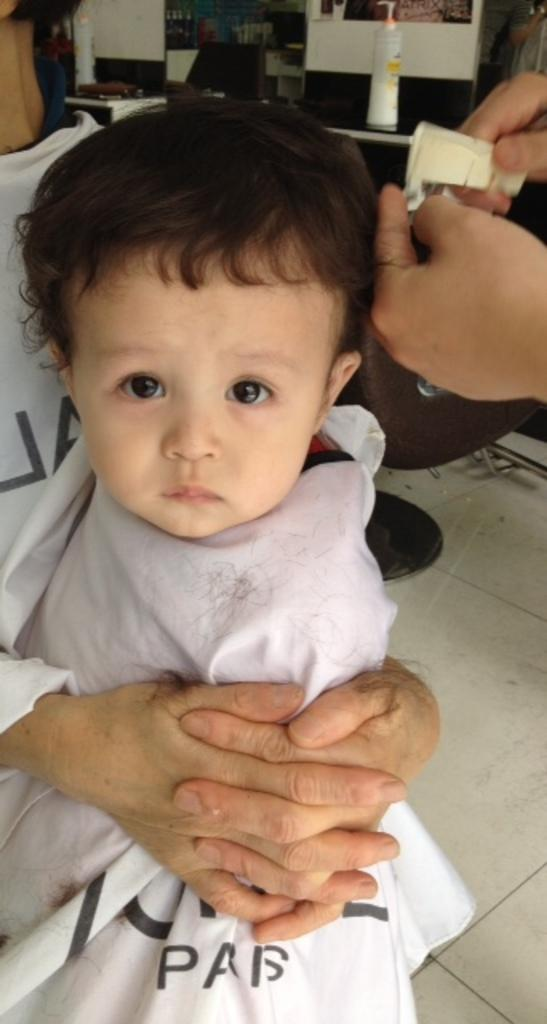How many people are in the image? There are a few people in the image. What can be seen on the ground in the image? The ground is visible in the image with some objects. What is visible in the background of the image? The background of the image contains some objects. How many nails can be seen in the image? There is no mention of nails in the image, so it cannot be determined how many there are. 